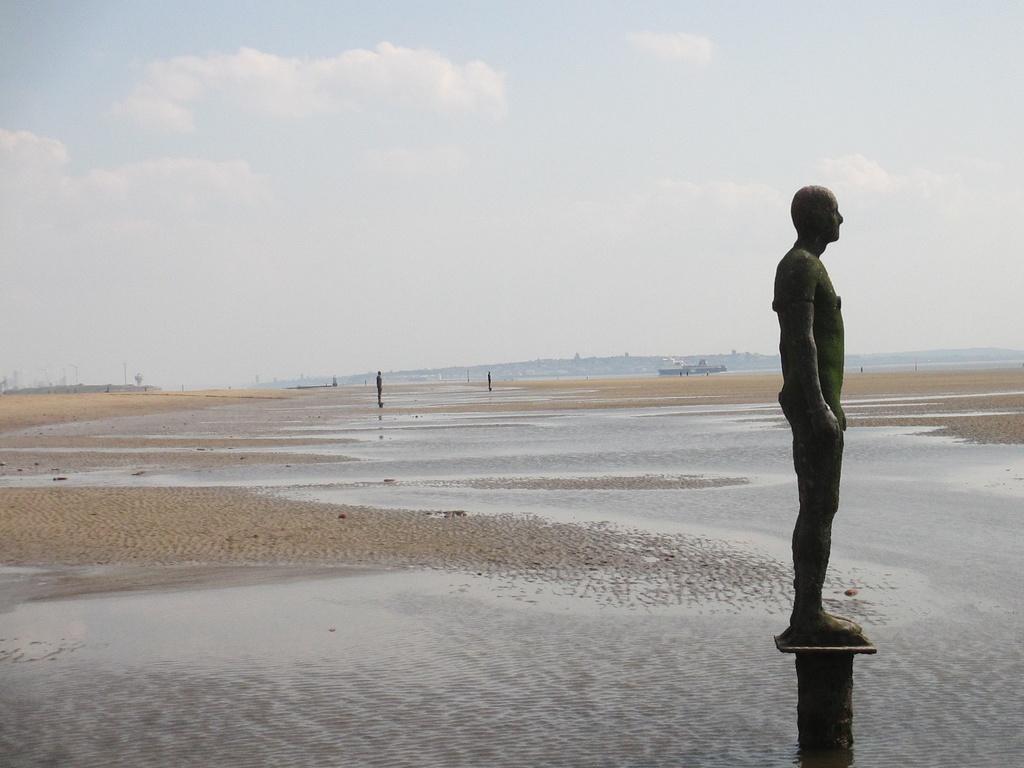Describe this image in one or two sentences. The picture is taken in a beach. In the foreground there are sand, water and a statue. In the background there are statues, sand, people, ship and hill. Sky is cloudy. 